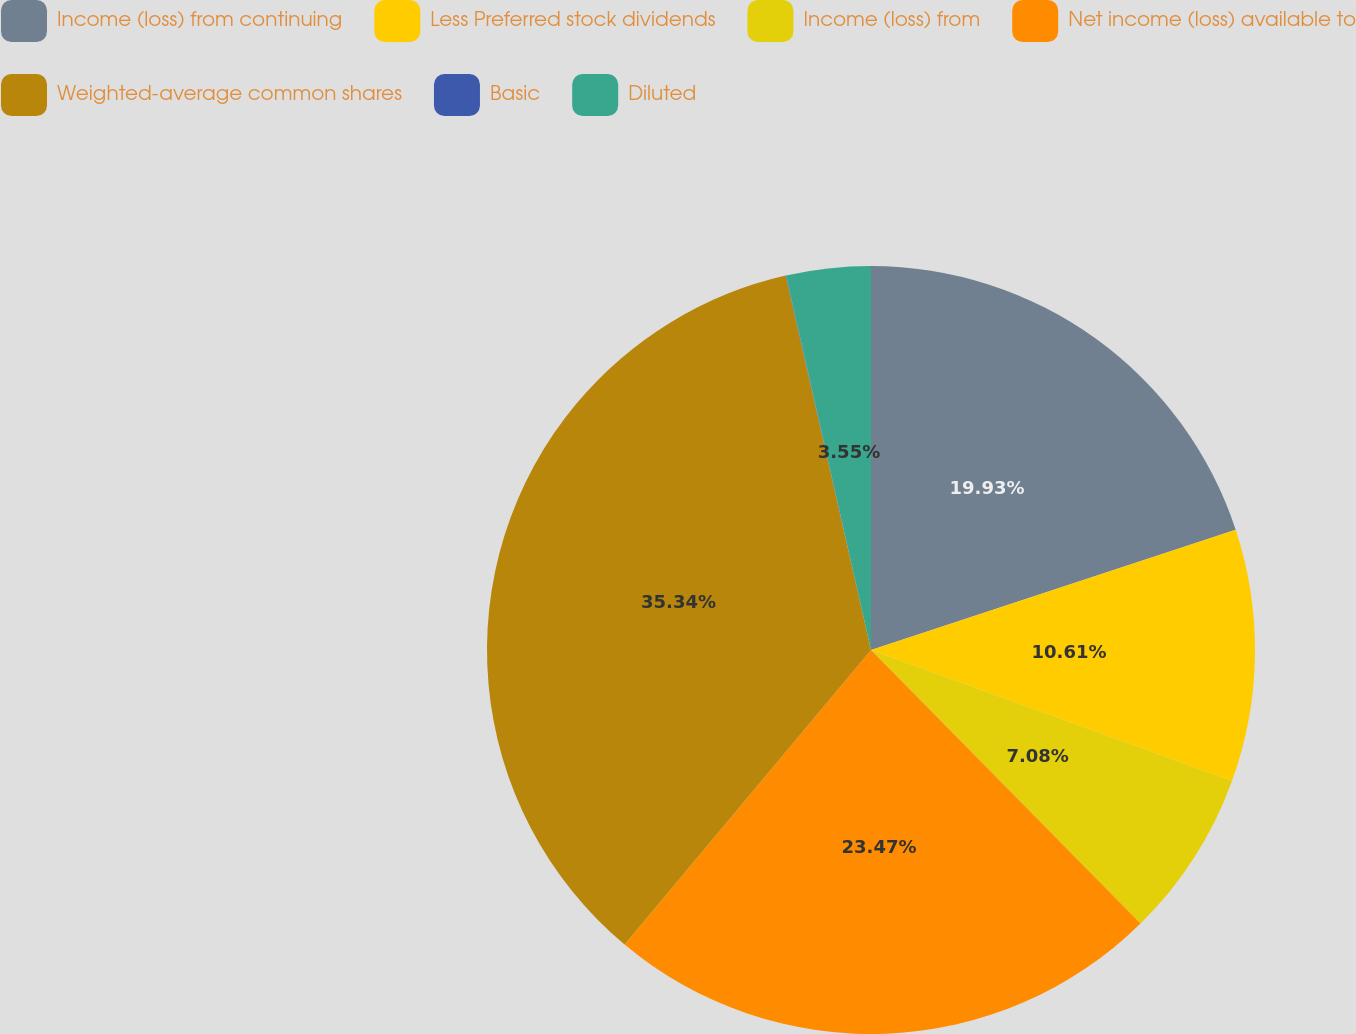<chart> <loc_0><loc_0><loc_500><loc_500><pie_chart><fcel>Income (loss) from continuing<fcel>Less Preferred stock dividends<fcel>Income (loss) from<fcel>Net income (loss) available to<fcel>Weighted-average common shares<fcel>Basic<fcel>Diluted<nl><fcel>19.93%<fcel>10.61%<fcel>7.08%<fcel>23.47%<fcel>35.34%<fcel>0.02%<fcel>3.55%<nl></chart> 